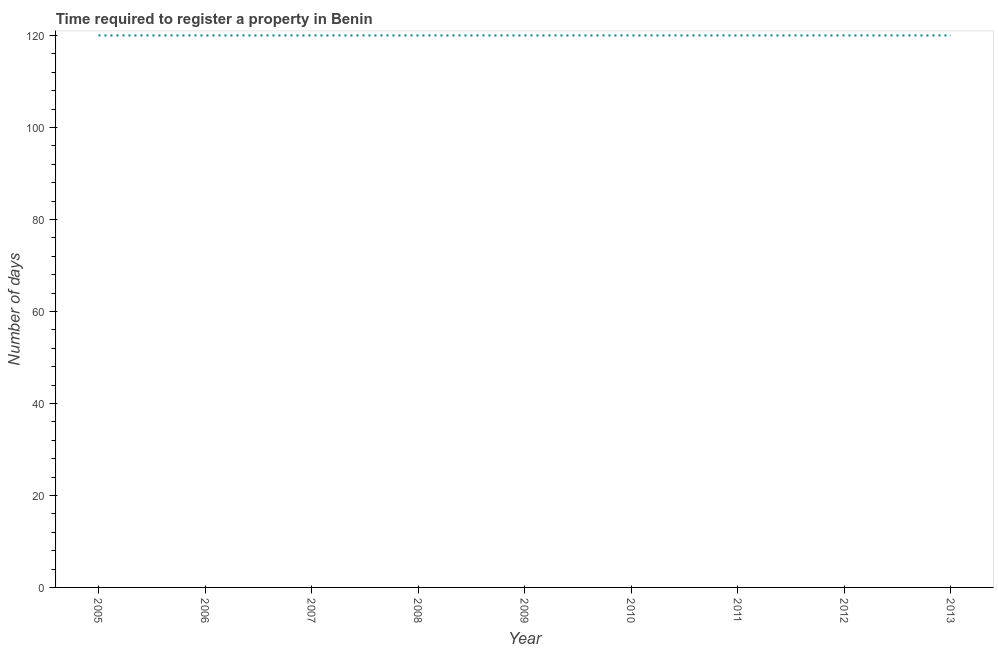What is the number of days required to register property in 2008?
Your answer should be very brief. 120. Across all years, what is the maximum number of days required to register property?
Give a very brief answer. 120. Across all years, what is the minimum number of days required to register property?
Your answer should be very brief. 120. What is the sum of the number of days required to register property?
Your answer should be very brief. 1080. What is the average number of days required to register property per year?
Offer a terse response. 120. What is the median number of days required to register property?
Offer a very short reply. 120. In how many years, is the number of days required to register property greater than 100 days?
Offer a terse response. 9. Do a majority of the years between 2012 and 2005 (inclusive) have number of days required to register property greater than 56 days?
Give a very brief answer. Yes. What is the ratio of the number of days required to register property in 2006 to that in 2008?
Keep it short and to the point. 1. Is the difference between the number of days required to register property in 2005 and 2011 greater than the difference between any two years?
Your response must be concise. Yes. Is the sum of the number of days required to register property in 2007 and 2013 greater than the maximum number of days required to register property across all years?
Ensure brevity in your answer.  Yes. In how many years, is the number of days required to register property greater than the average number of days required to register property taken over all years?
Ensure brevity in your answer.  0. Does the number of days required to register property monotonically increase over the years?
Your answer should be very brief. No. How many years are there in the graph?
Give a very brief answer. 9. Does the graph contain any zero values?
Give a very brief answer. No. What is the title of the graph?
Offer a very short reply. Time required to register a property in Benin. What is the label or title of the X-axis?
Keep it short and to the point. Year. What is the label or title of the Y-axis?
Your response must be concise. Number of days. What is the Number of days of 2005?
Provide a succinct answer. 120. What is the Number of days of 2006?
Keep it short and to the point. 120. What is the Number of days in 2007?
Provide a succinct answer. 120. What is the Number of days in 2008?
Ensure brevity in your answer.  120. What is the Number of days in 2009?
Offer a terse response. 120. What is the Number of days of 2010?
Your response must be concise. 120. What is the Number of days in 2011?
Offer a terse response. 120. What is the Number of days in 2012?
Your answer should be compact. 120. What is the Number of days of 2013?
Make the answer very short. 120. What is the difference between the Number of days in 2005 and 2006?
Your answer should be compact. 0. What is the difference between the Number of days in 2005 and 2010?
Provide a short and direct response. 0. What is the difference between the Number of days in 2006 and 2007?
Provide a short and direct response. 0. What is the difference between the Number of days in 2006 and 2011?
Provide a succinct answer. 0. What is the difference between the Number of days in 2006 and 2012?
Offer a terse response. 0. What is the difference between the Number of days in 2007 and 2008?
Offer a very short reply. 0. What is the difference between the Number of days in 2007 and 2009?
Make the answer very short. 0. What is the difference between the Number of days in 2007 and 2012?
Ensure brevity in your answer.  0. What is the difference between the Number of days in 2008 and 2013?
Offer a very short reply. 0. What is the difference between the Number of days in 2009 and 2010?
Your answer should be very brief. 0. What is the difference between the Number of days in 2009 and 2012?
Offer a very short reply. 0. What is the difference between the Number of days in 2009 and 2013?
Offer a terse response. 0. What is the difference between the Number of days in 2010 and 2011?
Provide a short and direct response. 0. What is the difference between the Number of days in 2011 and 2013?
Give a very brief answer. 0. What is the ratio of the Number of days in 2005 to that in 2008?
Offer a terse response. 1. What is the ratio of the Number of days in 2005 to that in 2010?
Give a very brief answer. 1. What is the ratio of the Number of days in 2005 to that in 2011?
Keep it short and to the point. 1. What is the ratio of the Number of days in 2006 to that in 2009?
Offer a very short reply. 1. What is the ratio of the Number of days in 2006 to that in 2012?
Offer a terse response. 1. What is the ratio of the Number of days in 2006 to that in 2013?
Ensure brevity in your answer.  1. What is the ratio of the Number of days in 2007 to that in 2009?
Your answer should be very brief. 1. What is the ratio of the Number of days in 2007 to that in 2010?
Provide a short and direct response. 1. What is the ratio of the Number of days in 2007 to that in 2012?
Ensure brevity in your answer.  1. What is the ratio of the Number of days in 2008 to that in 2010?
Your answer should be compact. 1. What is the ratio of the Number of days in 2008 to that in 2011?
Give a very brief answer. 1. What is the ratio of the Number of days in 2008 to that in 2012?
Give a very brief answer. 1. What is the ratio of the Number of days in 2008 to that in 2013?
Offer a very short reply. 1. What is the ratio of the Number of days in 2009 to that in 2010?
Your answer should be very brief. 1. What is the ratio of the Number of days in 2009 to that in 2013?
Offer a very short reply. 1. What is the ratio of the Number of days in 2010 to that in 2012?
Give a very brief answer. 1. What is the ratio of the Number of days in 2011 to that in 2012?
Make the answer very short. 1. 